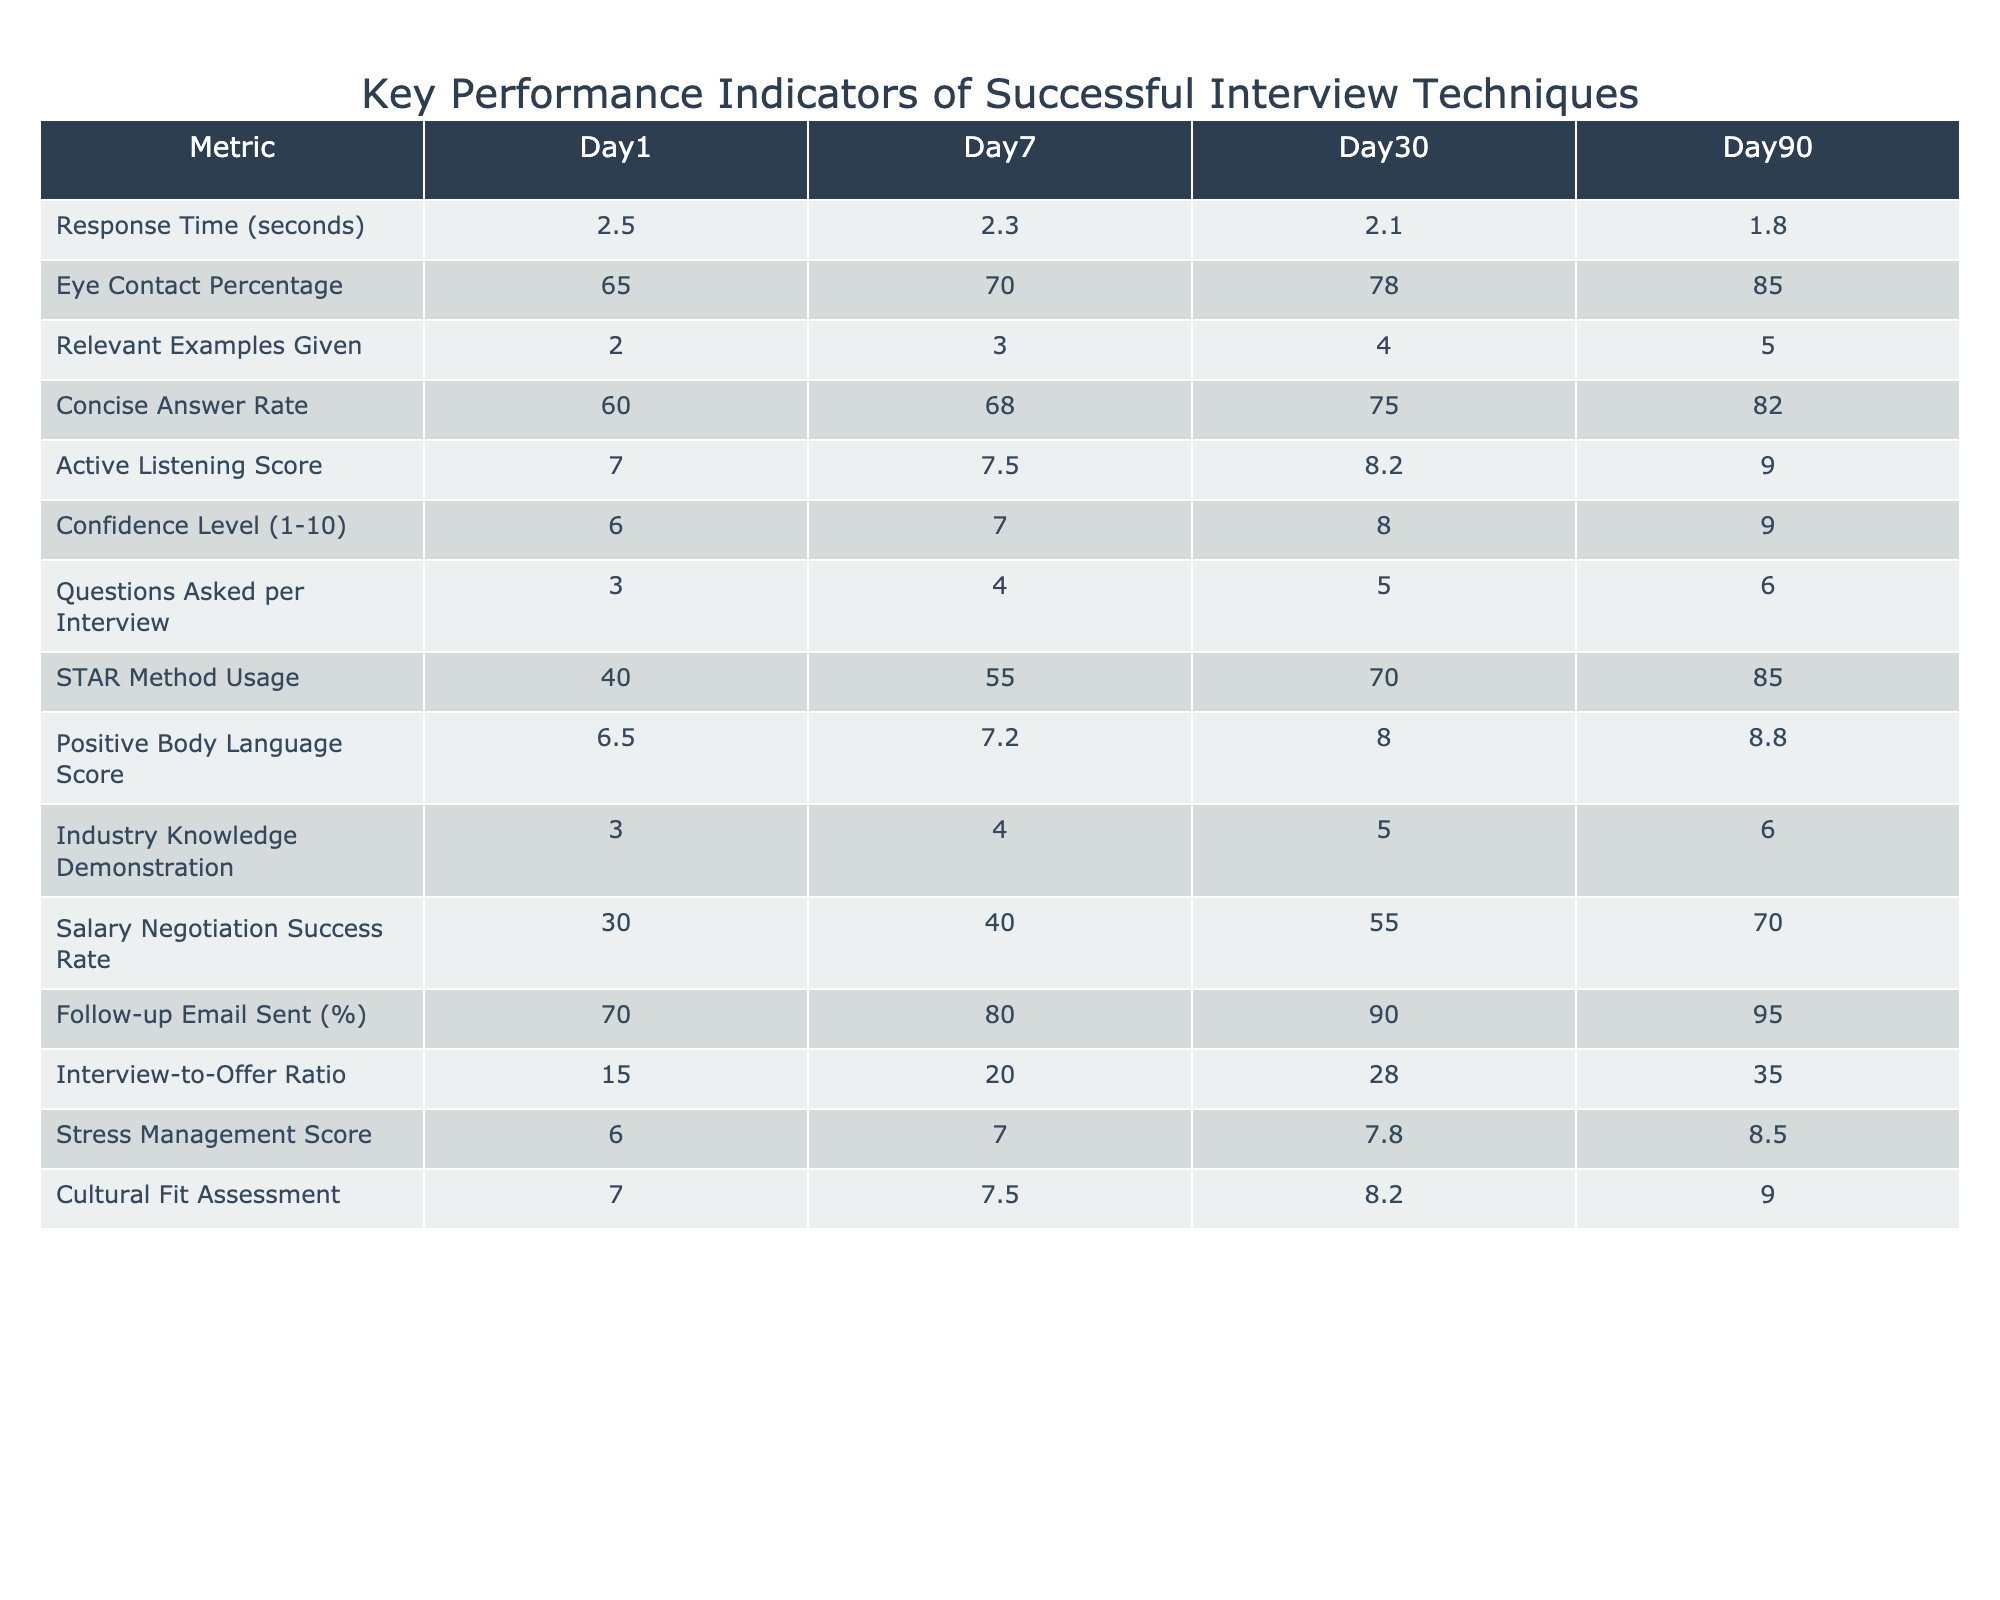What is the response time on Day 30? According to the table, the response time listed under Day 30 is 2.1 seconds.
Answer: 2.1 seconds What percentage of eye contact is observed on Day 90? The table indicates that the eye contact percentage on Day 90 is 85%.
Answer: 85% How many relevant examples are given on Day 7? The table shows that the number of relevant examples given on Day 7 is 3.
Answer: 3 What is the difference in the confidence level between Day 1 and Day 90? On Day 1, the confidence level is 6, and on Day 90, it is 9. The difference is 9 - 6 = 3.
Answer: 3 What is the average positive body language score across all days? The scores across the four days are 6.5, 7.2, 8, and 8.8. To find the average, sum these values: 6.5 + 7.2 + 8 + 8.8 = 30.5, and then divide by 4, resulting in an average of 30.5 / 4 = 7.625.
Answer: 7.625 Is the salary negotiation success rate above 60% on Day 30? The table shows that the salary negotiation success rate on Day 30 is 55%, which is not above 60%.
Answer: No What is the trend in the follow-up email sent percentage from Day 1 to Day 90? We see the follow-up email percentage starts at 70% on Day 1 and increases to 95% on Day 90, indicating a positive trend over the days.
Answer: Positive trend How much has the STAR method usage increased from Day 1 to Day 90? The STAR method usage on Day 1 is 40%, and on Day 90 it is 85%. The increase is 85% - 40% = 45%.
Answer: 45% Which day shows the highest score for stress management? The table indicates that the stress management score is highest on Day 90 at 8.5.
Answer: Day 90 Calculate the total number of questions asked during interviews by Day 30. The table shows that the number of questions asked per interview is 5 on Day 30. Since that is the only Day 30 data needed, the total is 5.
Answer: 5 How does the active listening score compare between Day 1 and Day 7? The active listening score is 7 on Day 1 and increases to 7.5 on Day 7, indicating an improvement of 0.5.
Answer: Increase of 0.5 